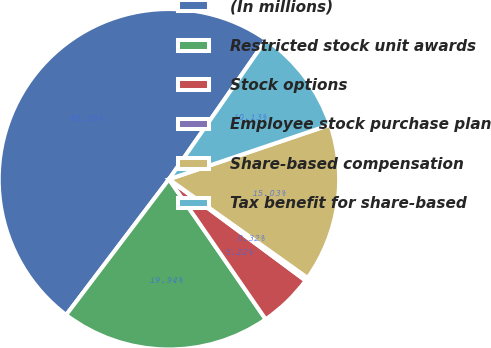Convert chart. <chart><loc_0><loc_0><loc_500><loc_500><pie_chart><fcel>(In millions)<fcel>Restricted stock unit awards<fcel>Stock options<fcel>Employee stock purchase plan<fcel>Share-based compensation<fcel>Tax benefit for share-based<nl><fcel>49.36%<fcel>19.94%<fcel>5.22%<fcel>0.32%<fcel>15.03%<fcel>10.13%<nl></chart> 